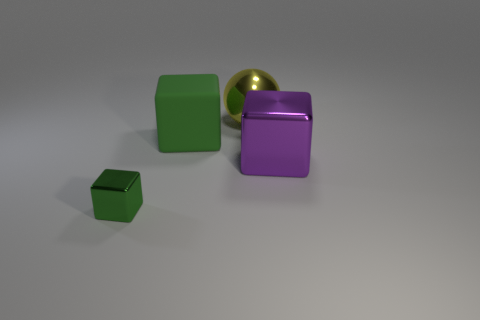Add 4 big metallic balls. How many objects exist? 8 Subtract all cubes. How many objects are left? 1 Subtract 0 blue blocks. How many objects are left? 4 Subtract all big metallic objects. Subtract all large green matte blocks. How many objects are left? 1 Add 1 spheres. How many spheres are left? 2 Add 1 big yellow rubber blocks. How many big yellow rubber blocks exist? 1 